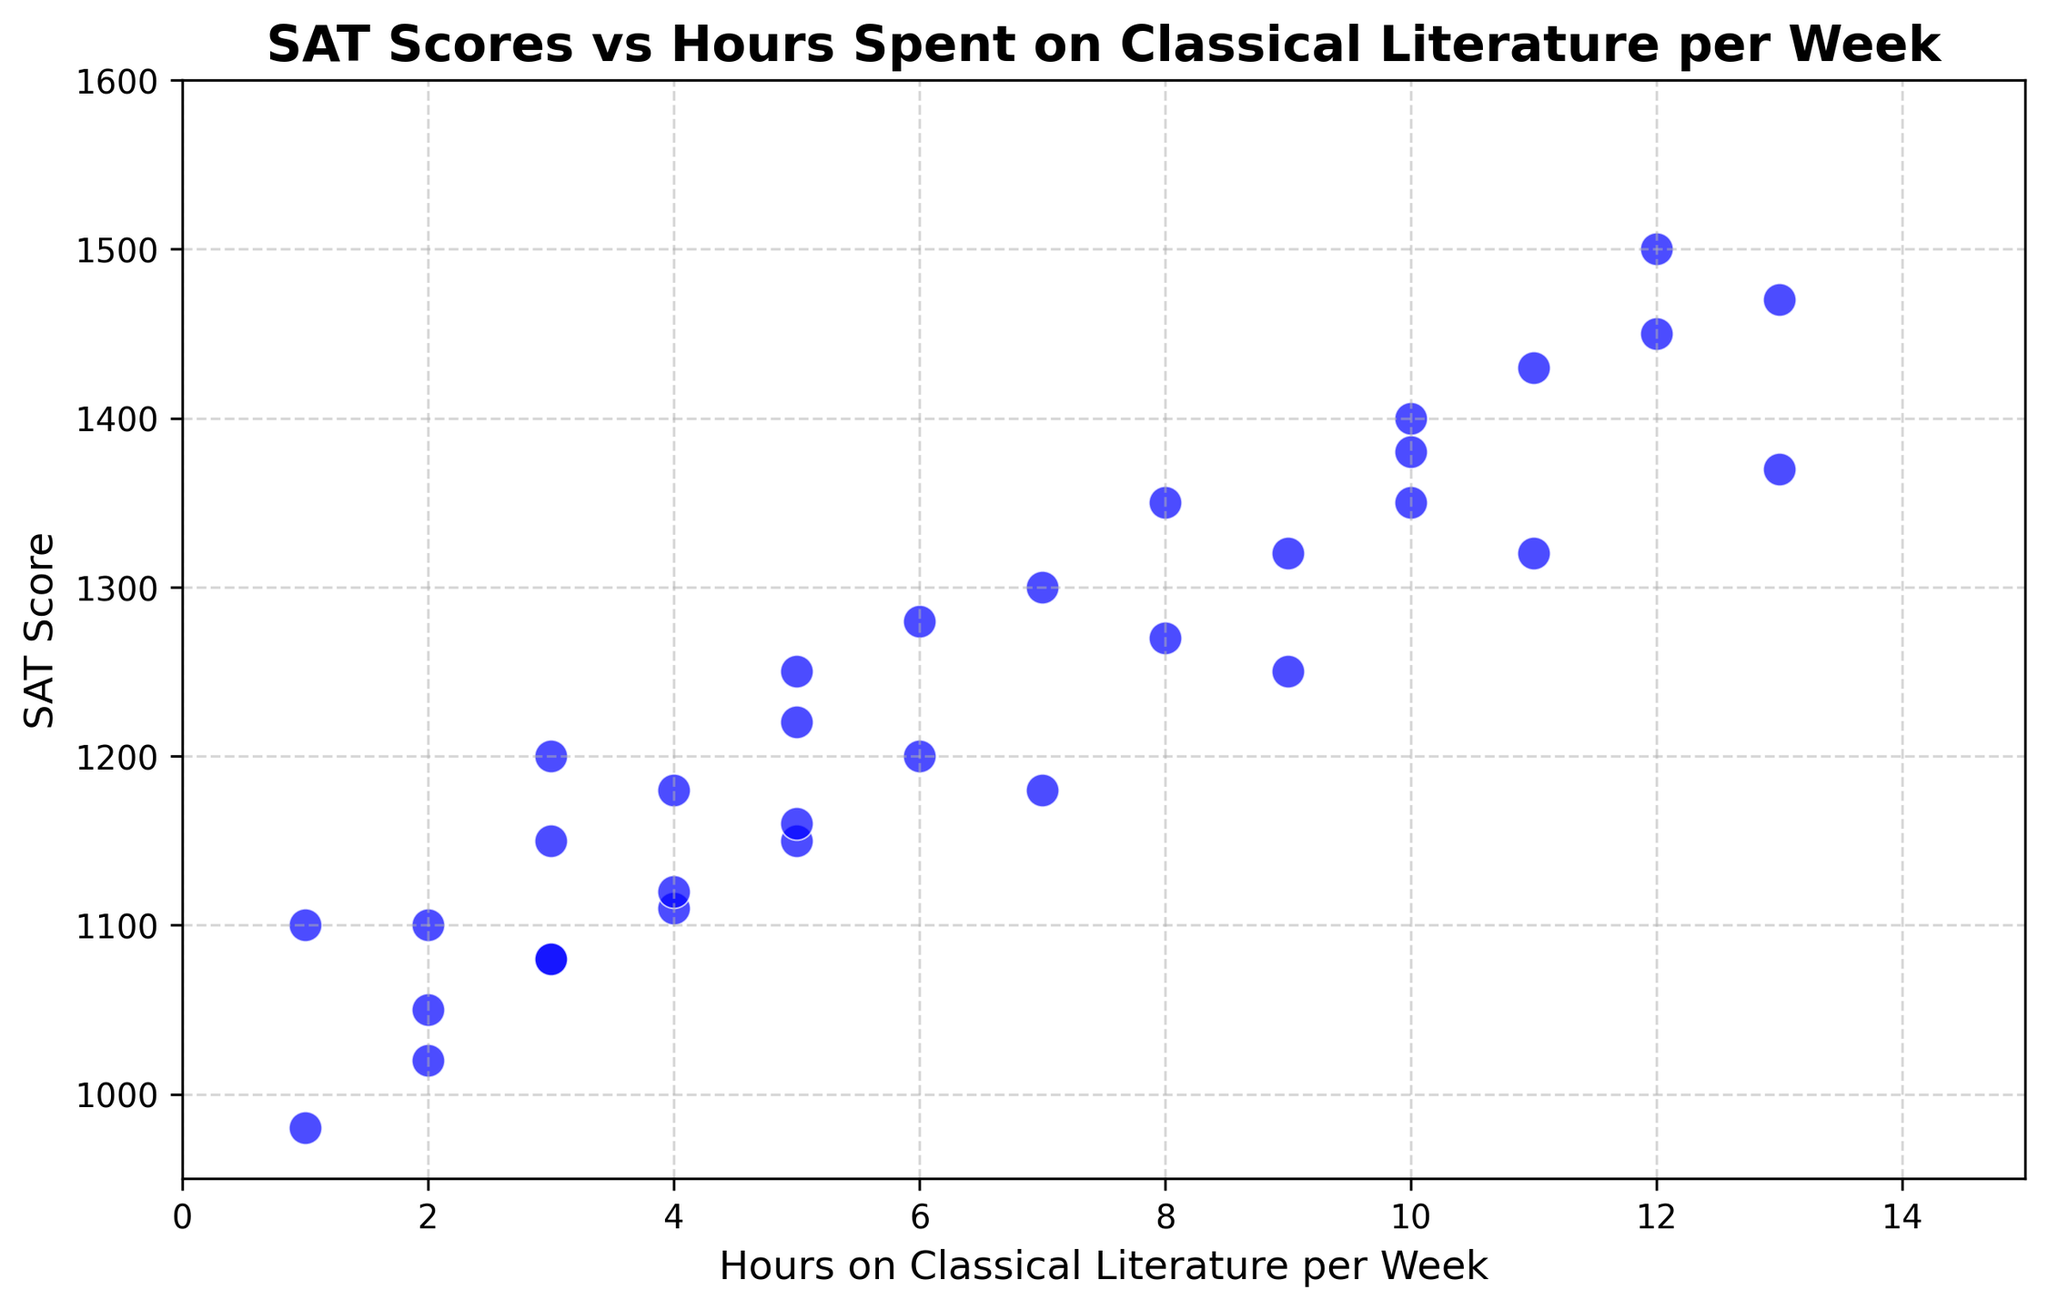What's the average SAT score for students who spend exactly 10 hours on classical literature per week? There are three data points for 10 hours per week: 1400, 1350, and 1350. To get the average, sum these values and divide by the number of data points. (1400 + 1350 + 1350) / 3 = 1370
Answer: 1370 Which SAT score corresponds to the highest number of hours spent on classical literature per week, and what is that number of hours? The highest number of hours spent on classical literature per week is 13. The corresponding SAT scores for 13 hours per week are 1470 and 1370. The higher of the two SAT scores is 1470
Answer: 1470 and 13 hours Is there a positive correlation between the number of hours spent on classical literature and SAT scores? Observing the scatter plot, most points seem to show a trend where higher hours on classical literature are associated with higher SAT scores, indicating a positive correlation
Answer: Yes What is the range of SAT scores for students who spend 5 hours per week on classical literature? The SAT scores for students who spend 5 hours per week on classical literature are 1250, 1220, and 1150. The range is calculated as the difference between the highest and lowest scores: 1250 - 1150 = 100
Answer: 100 Which student spent the least time on classical literature, and what was their SAT score? The least time spent on classical literature is 1 hour per week. The corresponding SAT scores are 1100 and 980. The lowest SAT score is 980
Answer: 980 What is the median SAT score for students who spend between 3 and 5 hours per week on classical literature? First, list the SAT scores for 3, 4, and 5 hours: 1200, 1150, 1080, 1180, 1220, 1250, 1110, 1120, and 1160. Sorting these values gives: 1080, 1110, 1120, 1150, 1160, 1180, 1200, 1220, 1250. The middle value (5th in this list) is 1160, so the median is 1160
Answer: 1160 